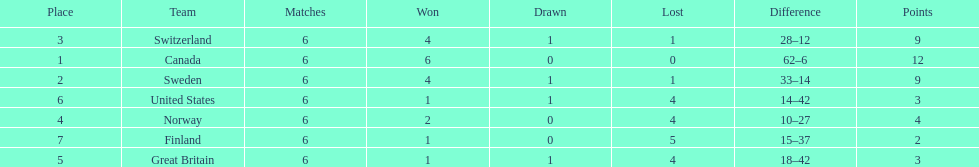Which team won more matches, finland or norway? Norway. Could you parse the entire table as a dict? {'header': ['Place', 'Team', 'Matches', 'Won', 'Drawn', 'Lost', 'Difference', 'Points'], 'rows': [['3', 'Switzerland', '6', '4', '1', '1', '28–12', '9'], ['1', 'Canada', '6', '6', '0', '0', '62–6', '12'], ['2', 'Sweden', '6', '4', '1', '1', '33–14', '9'], ['6', 'United States', '6', '1', '1', '4', '14–42', '3'], ['4', 'Norway', '6', '2', '0', '4', '10–27', '4'], ['7', 'Finland', '6', '1', '0', '5', '15–37', '2'], ['5', 'Great Britain', '6', '1', '1', '4', '18–42', '3']]} 